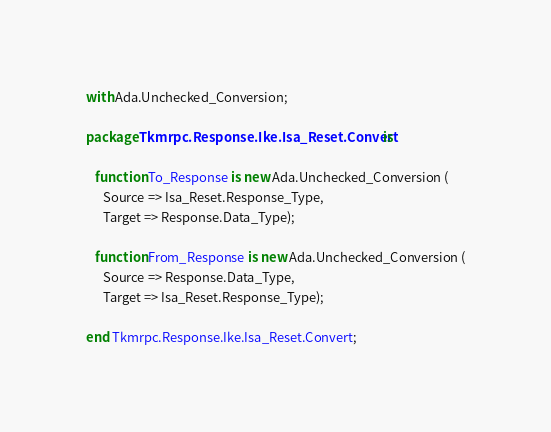<code> <loc_0><loc_0><loc_500><loc_500><_Ada_>with Ada.Unchecked_Conversion;

package Tkmrpc.Response.Ike.Isa_Reset.Convert is

   function To_Response is new Ada.Unchecked_Conversion (
      Source => Isa_Reset.Response_Type,
      Target => Response.Data_Type);

   function From_Response is new Ada.Unchecked_Conversion (
      Source => Response.Data_Type,
      Target => Isa_Reset.Response_Type);

end Tkmrpc.Response.Ike.Isa_Reset.Convert;
</code> 